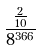Convert formula to latex. <formula><loc_0><loc_0><loc_500><loc_500>\frac { \frac { 2 } { 1 0 } } { 8 ^ { 3 6 6 } }</formula> 